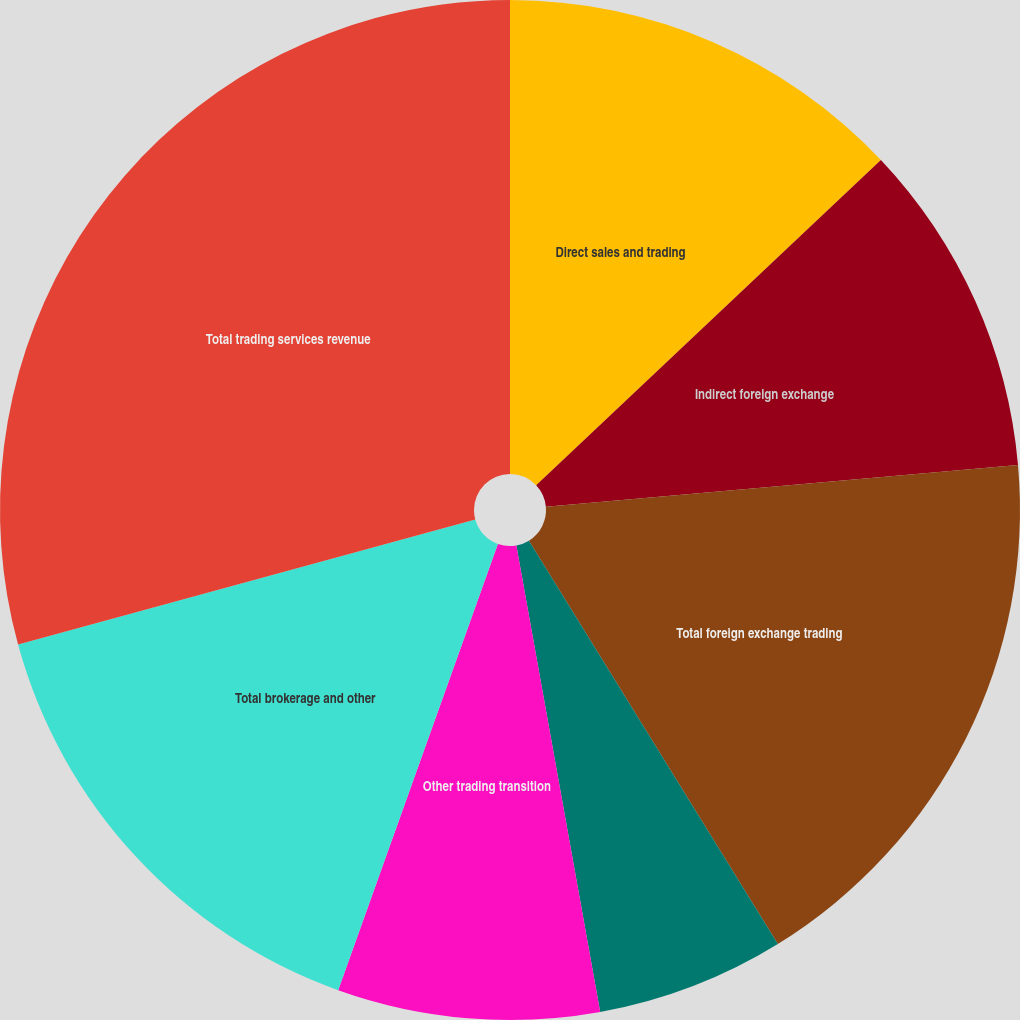<chart> <loc_0><loc_0><loc_500><loc_500><pie_chart><fcel>Direct sales and trading<fcel>Indirect foreign exchange<fcel>Total foreign exchange trading<fcel>Electronic foreign exchange<fcel>Other trading transition<fcel>Total brokerage and other<fcel>Total trading services revenue<nl><fcel>12.96%<fcel>10.63%<fcel>17.61%<fcel>5.97%<fcel>8.3%<fcel>15.28%<fcel>29.25%<nl></chart> 